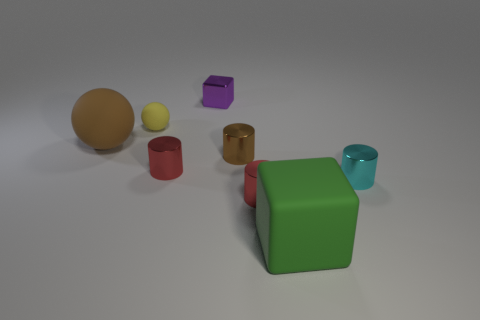There is a red object that is in front of the tiny cyan metal cylinder; how big is it?
Offer a very short reply. Small. What is the large object that is in front of the small cyan metal object made of?
Your response must be concise. Rubber. How many red objects are big cubes or small rubber things?
Your response must be concise. 0. Do the green block and the brown thing behind the brown metallic thing have the same material?
Your answer should be compact. Yes. Are there the same number of red things on the left side of the tiny purple object and small things on the right side of the brown metallic object?
Ensure brevity in your answer.  No. There is a cyan object; is it the same size as the cube behind the yellow object?
Make the answer very short. Yes. Are there more rubber objects that are to the left of the yellow matte sphere than large cyan cylinders?
Offer a terse response. Yes. How many metal cubes are the same size as the brown ball?
Ensure brevity in your answer.  0. Is the size of the block left of the rubber cube the same as the rubber object that is on the right side of the small brown cylinder?
Ensure brevity in your answer.  No. Are there more tiny red cylinders in front of the big green rubber block than metallic things that are to the left of the tiny cyan thing?
Provide a succinct answer. No. 